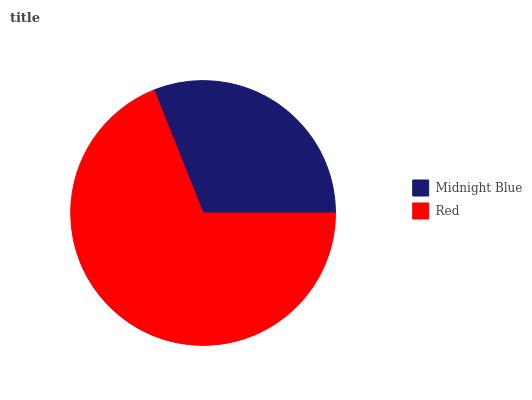Is Midnight Blue the minimum?
Answer yes or no. Yes. Is Red the maximum?
Answer yes or no. Yes. Is Red the minimum?
Answer yes or no. No. Is Red greater than Midnight Blue?
Answer yes or no. Yes. Is Midnight Blue less than Red?
Answer yes or no. Yes. Is Midnight Blue greater than Red?
Answer yes or no. No. Is Red less than Midnight Blue?
Answer yes or no. No. Is Red the high median?
Answer yes or no. Yes. Is Midnight Blue the low median?
Answer yes or no. Yes. Is Midnight Blue the high median?
Answer yes or no. No. Is Red the low median?
Answer yes or no. No. 